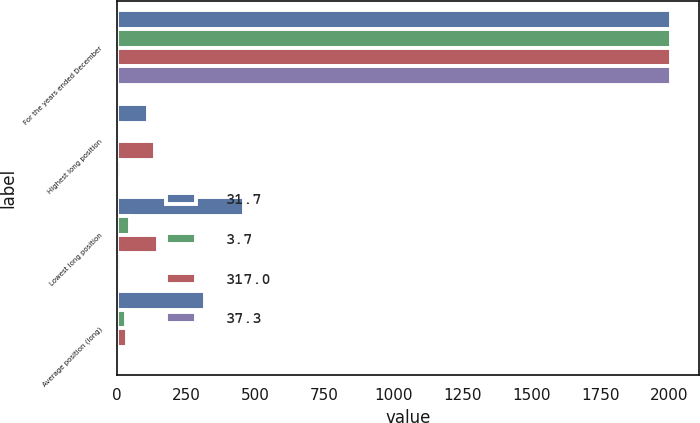Convert chart to OTSL. <chart><loc_0><loc_0><loc_500><loc_500><stacked_bar_chart><ecel><fcel>For the years ended December<fcel>Highest long position<fcel>Lowest long position<fcel>Average position (long)<nl><fcel>31.7<fcel>2007<fcel>112.5<fcel>460.9<fcel>317<nl><fcel>3.7<fcel>2007<fcel>11.3<fcel>46.1<fcel>31.7<nl><fcel>317<fcel>2006<fcel>138.4<fcel>147<fcel>37.3<nl><fcel>37.3<fcel>2006<fcel>13.8<fcel>14.7<fcel>3.7<nl></chart> 